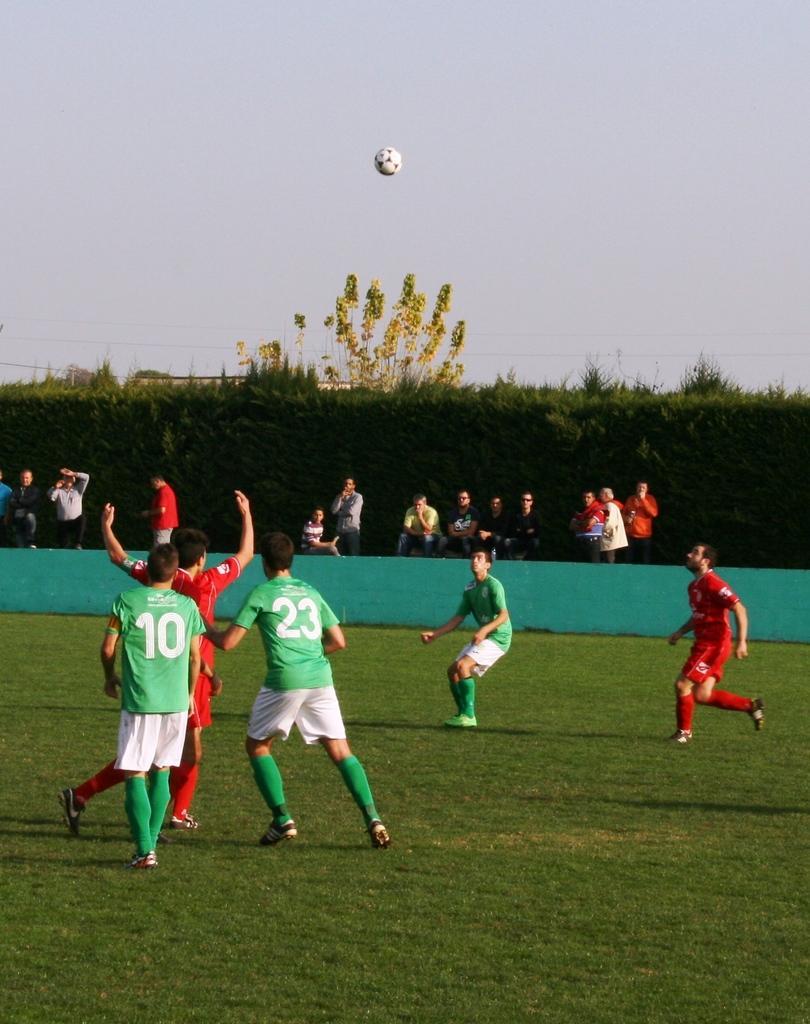Please provide a concise description of this image. In this image there is a green grass at the bottom. There are people, ball and wall in the foreground. There are people, small plants and grass in the background. There is a sky at the top. 